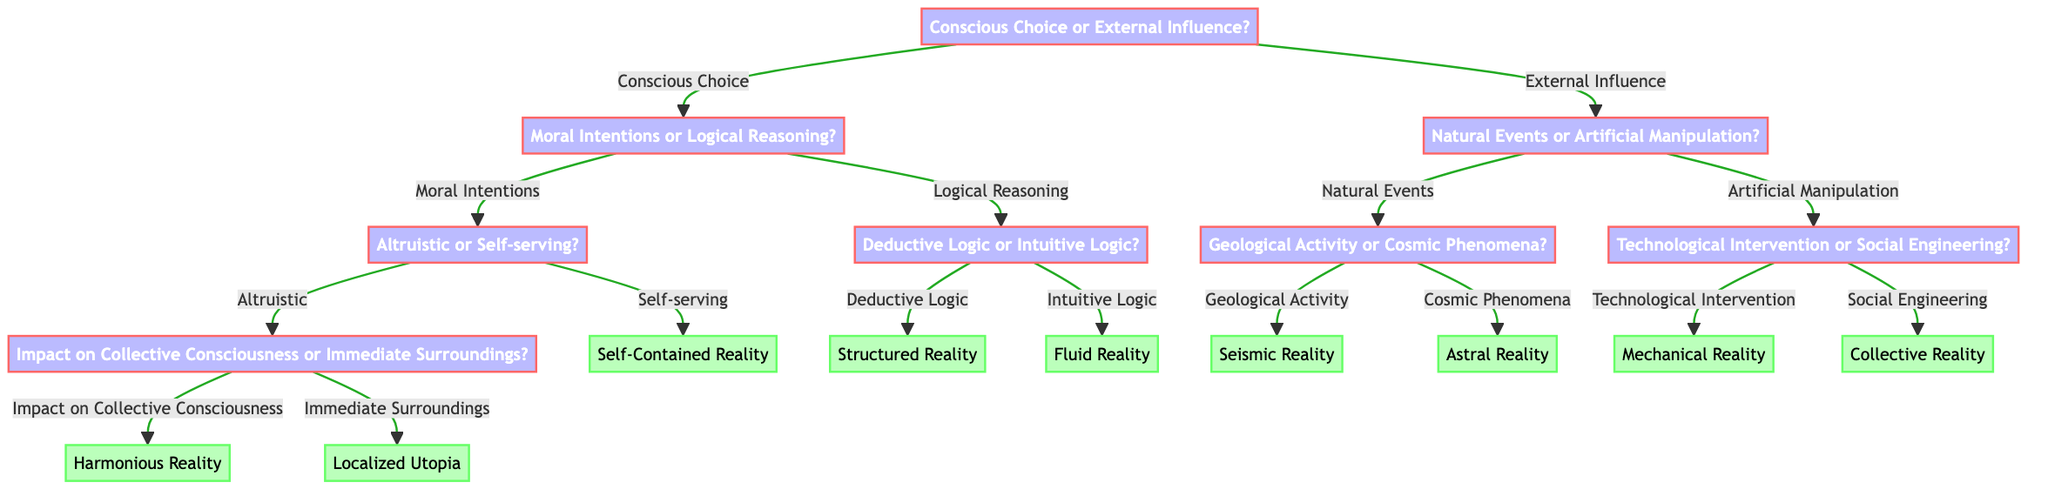What is the first decision point in the diagram? The first decision point is whether to choose between "Conscious Choice or External Influence." This is the root of the decision tree that branches out into different paths based on the choice made.
Answer: Conscious Choice or External Influence How many branches stem from the decision "Conscious Choice"? The decision "Conscious Choice" has two branches that stem from it: "Moral Intentions" and "Logical Reasoning." Each branch leads to further decisions.
Answer: 2 What type of reality is associated with "Altruistic" intentions that impact the "Collective Consciousness"? The "Altruistic" intentions that impact the "Collective Consciousness" lead to a "Harmonious Reality." This result signifies an outcome that supports overall unity and balance in consciousness.
Answer: Harmonious Reality If one chooses "Technological Intervention," what is the resulting reality? Choosing "Technological Intervention" results in a "Mechanical Reality." This outcome suggests that the influence of technology shapes the nature of reality in a structured and artificial way.
Answer: Mechanical Reality What is the relationship between "Immediate Surroundings" and its resulting reality? The "Immediate Surroundings" decision leads to the result "Localized Utopia." This indicates a focus on creating an ideal environment in a specific locality, rather than a broader impact.
Answer: Localized Utopia Which branch leads to "Fluid Reality"? "Fluid Reality" is reached by navigating the "Conscious Choice" to "Logical Reasoning" and then choosing "Intuitive Logic." This process illustrates a decision that embraces adaptability and spontaneity in the nature of reality.
Answer: Intuitive Logic What is the outcome of “Cosmic Phenomena”? The decision point "Cosmic Phenomena" under "Natural Events" leads to the resultant reality of "Astral Reality." This indicates that cosmic influences shape the nature of existence in a celestial context.
Answer: Astral Reality Which decision leads to a "Self-Contained Reality"? The decision "Self-serving" under "Moral Intentions" directly leads to the outcome of a "Self-Contained Reality." This suggests that choices motivated by selfishness result in an isolated or individualistic type of reality.
Answer: Self-Contained Reality How many total results are present in the diagram? The diagram presents a total of eight distinct results which are outcomes derived from the various decision paths throughout the tree.
Answer: 8 